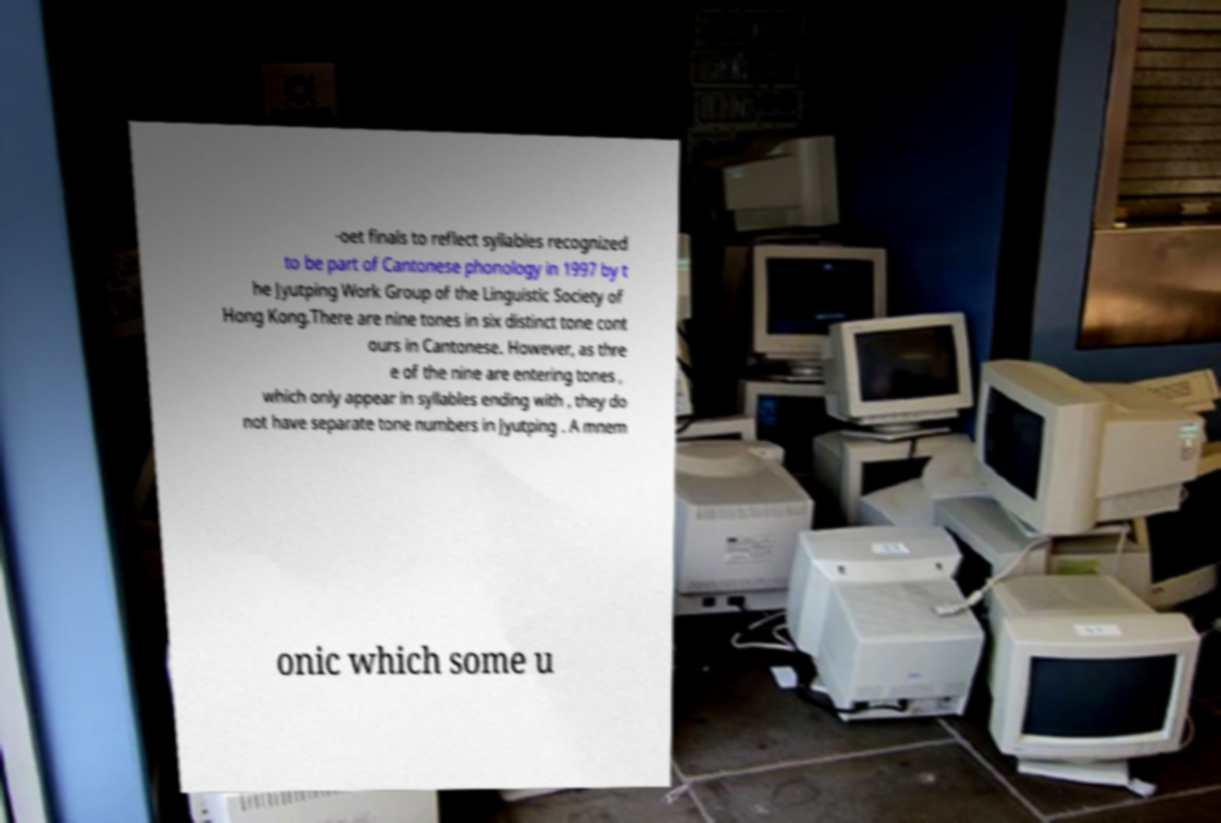I need the written content from this picture converted into text. Can you do that? -oet finals to reflect syllables recognized to be part of Cantonese phonology in 1997 by t he Jyutping Work Group of the Linguistic Society of Hong Kong.There are nine tones in six distinct tone cont ours in Cantonese. However, as thre e of the nine are entering tones , which only appear in syllables ending with , they do not have separate tone numbers in Jyutping . A mnem onic which some u 